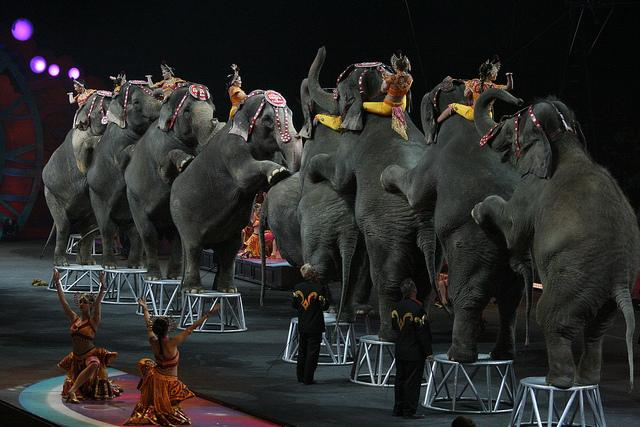What are the elephants doing? Please explain your reasoning. performing. The elephants are at a circus doing their routine. 